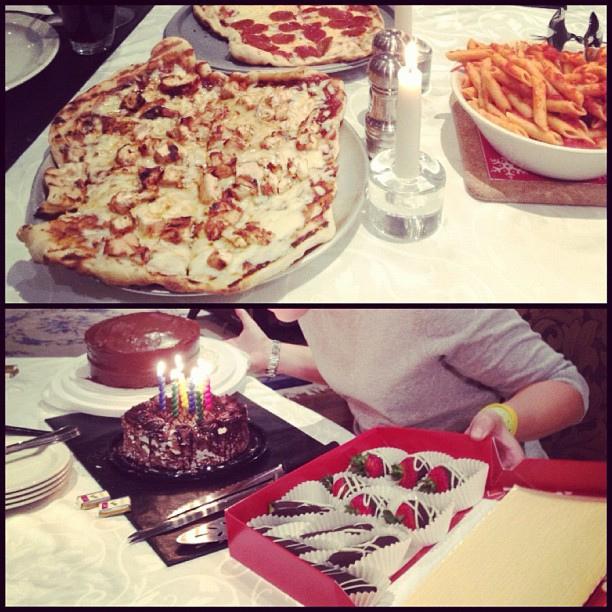How much pizza has been taken?
Be succinct. 0. What dish is on the table?
Answer briefly. Pizza. Is somebody celebrating a birthday?
Short answer required. Yes. What kind of food is this?
Write a very short answer. Pizza. Which course of a meal do think this would be?
Quick response, please. Dinner. What kinds of food is visible?
Write a very short answer. Pizza, pasta, cake, and pastries. 